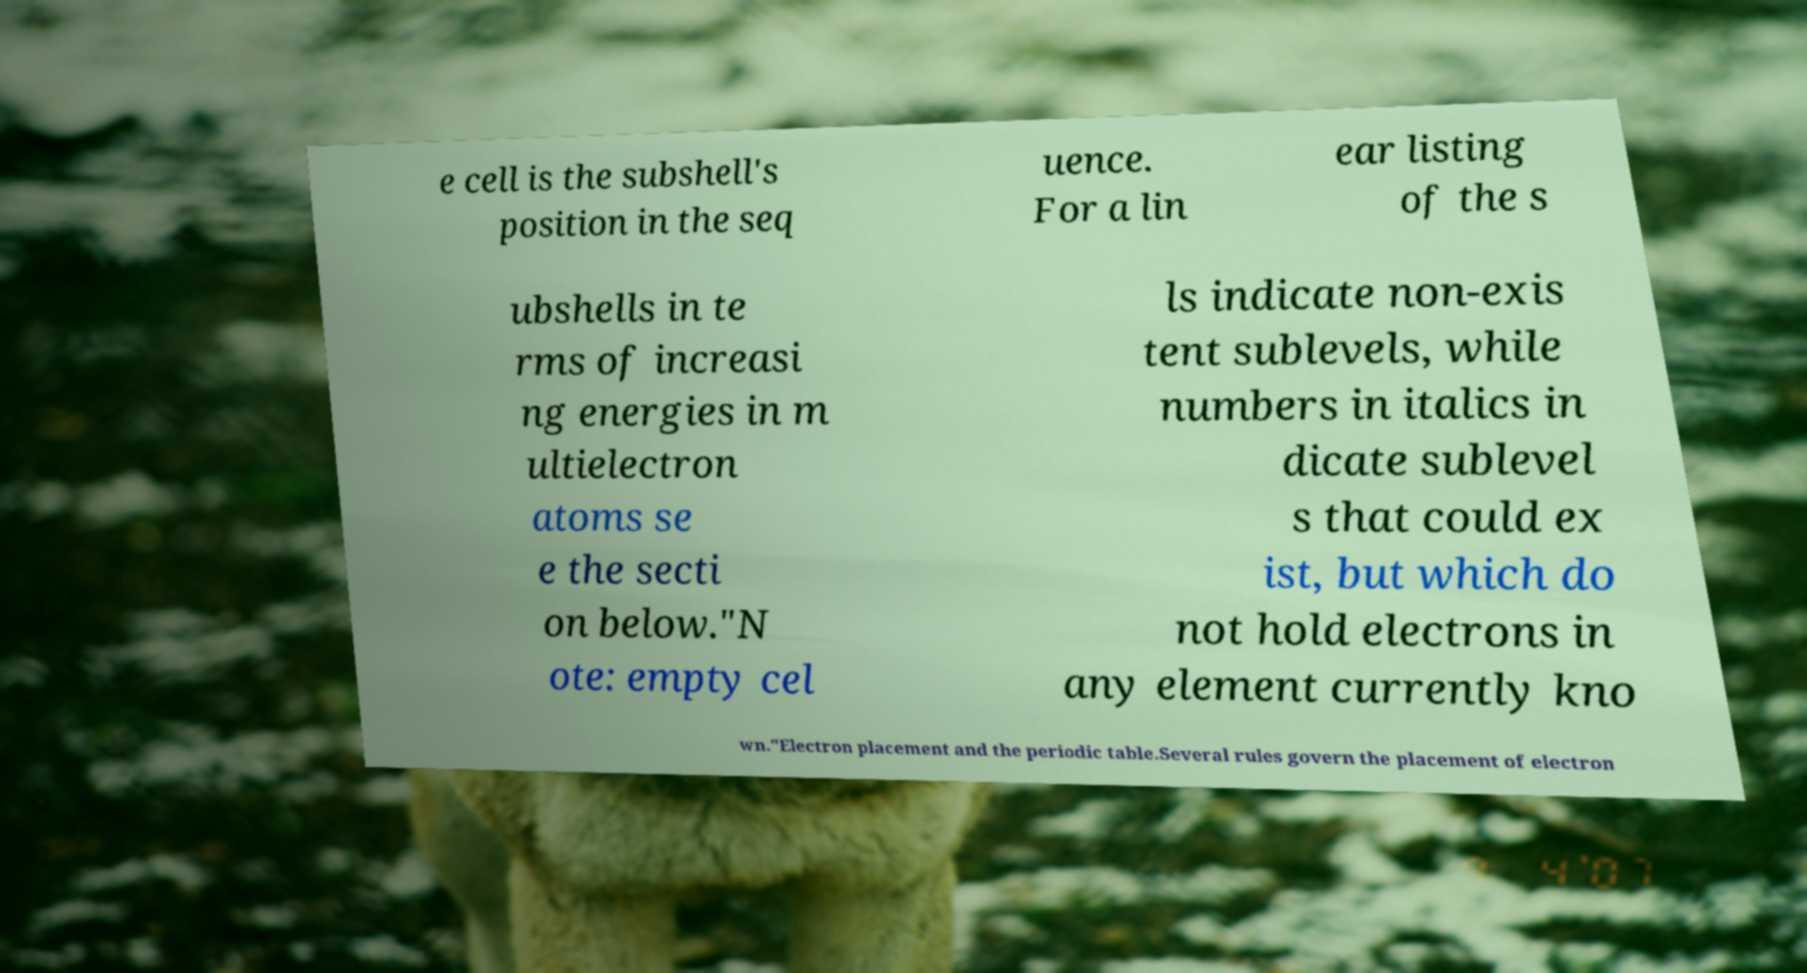There's text embedded in this image that I need extracted. Can you transcribe it verbatim? e cell is the subshell's position in the seq uence. For a lin ear listing of the s ubshells in te rms of increasi ng energies in m ultielectron atoms se e the secti on below."N ote: empty cel ls indicate non-exis tent sublevels, while numbers in italics in dicate sublevel s that could ex ist, but which do not hold electrons in any element currently kno wn."Electron placement and the periodic table.Several rules govern the placement of electron 